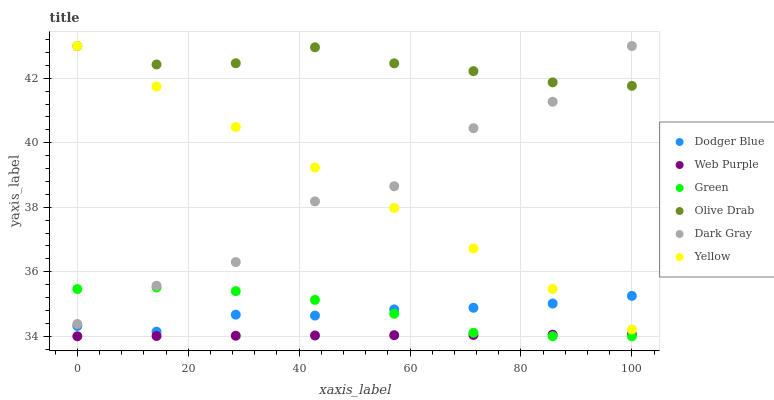Does Web Purple have the minimum area under the curve?
Answer yes or no. Yes. Does Olive Drab have the maximum area under the curve?
Answer yes or no. Yes. Does Dark Gray have the minimum area under the curve?
Answer yes or no. No. Does Dark Gray have the maximum area under the curve?
Answer yes or no. No. Is Yellow the smoothest?
Answer yes or no. Yes. Is Dark Gray the roughest?
Answer yes or no. Yes. Is Web Purple the smoothest?
Answer yes or no. No. Is Web Purple the roughest?
Answer yes or no. No. Does Web Purple have the lowest value?
Answer yes or no. Yes. Does Dark Gray have the lowest value?
Answer yes or no. No. Does Olive Drab have the highest value?
Answer yes or no. Yes. Does Web Purple have the highest value?
Answer yes or no. No. Is Green less than Yellow?
Answer yes or no. Yes. Is Olive Drab greater than Dodger Blue?
Answer yes or no. Yes. Does Olive Drab intersect Dark Gray?
Answer yes or no. Yes. Is Olive Drab less than Dark Gray?
Answer yes or no. No. Is Olive Drab greater than Dark Gray?
Answer yes or no. No. Does Green intersect Yellow?
Answer yes or no. No. 